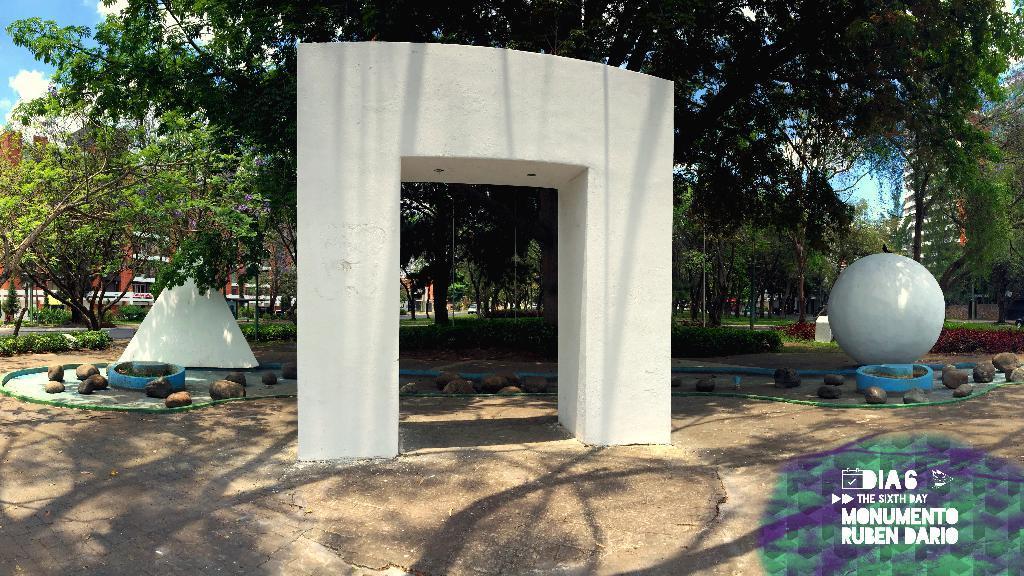Please provide a concise description of this image. In this picture I can observe some trees. There are some stones in the middle of the picture. In the bottom right side I can observe watermark. In the background I can observe sky. 